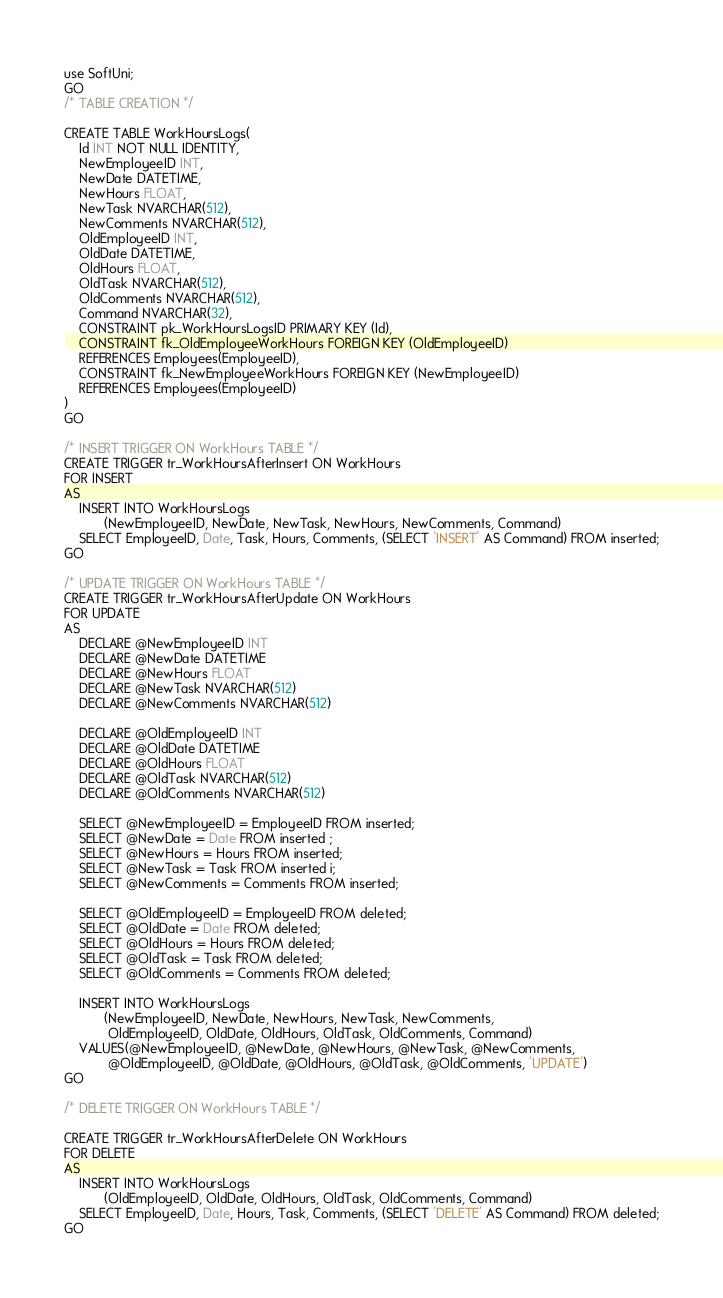Convert code to text. <code><loc_0><loc_0><loc_500><loc_500><_SQL_>use SoftUni;
GO
/* TABLE CREATION */

CREATE TABLE WorkHoursLogs(
	Id INT NOT NULL IDENTITY,
	NewEmployeeID INT,
	NewDate DATETIME,
	NewHours FLOAT,
	NewTask NVARCHAR(512),
	NewComments NVARCHAR(512),
	OldEmployeeID INT,
	OldDate DATETIME,
	OldHours FLOAT,
	OldTask NVARCHAR(512),
	OldComments NVARCHAR(512),
	Command NVARCHAR(32),
	CONSTRAINT pk_WorkHoursLogsID PRIMARY KEY (Id),
	CONSTRAINT fk_OldEmployeeWorkHours FOREIGN KEY (OldEmployeeID)
	REFERENCES Employees(EmployeeID),
	CONSTRAINT fk_NewEmployeeWorkHours FOREIGN KEY (NewEmployeeID)
	REFERENCES Employees(EmployeeID)
)
GO

/* INSERT TRIGGER ON WorkHours TABLE */
CREATE TRIGGER tr_WorkHoursAfterInsert ON WorkHours 
FOR INSERT
AS
	INSERT INTO WorkHoursLogs
           (NewEmployeeID, NewDate, NewTask, NewHours, NewComments, Command) 
	SELECT EmployeeID, Date, Task, Hours, Comments, (SELECT 'INSERT' AS Command) FROM inserted;
GO

/* UPDATE TRIGGER ON WorkHours TABLE */
CREATE TRIGGER tr_WorkHoursAfterUpdate ON WorkHours 
FOR UPDATE
AS
	DECLARE @NewEmployeeID INT
	DECLARE @NewDate DATETIME
	DECLARE @NewHours FLOAT
	DECLARE @NewTask NVARCHAR(512)
	DECLARE @NewComments NVARCHAR(512)

	DECLARE @OldEmployeeID INT
	DECLARE @OldDate DATETIME
	DECLARE @OldHours FLOAT
	DECLARE @OldTask NVARCHAR(512)
	DECLARE @OldComments NVARCHAR(512)

	SELECT @NewEmployeeID = EmployeeID FROM inserted;	
	SELECT @NewDate = Date FROM inserted ;
	SELECT @NewHours = Hours FROM inserted;
	SELECT @NewTask = Task FROM inserted i;
	SELECT @NewComments = Comments FROM inserted;

	SELECT @OldEmployeeID = EmployeeID FROM deleted;	
	SELECT @OldDate = Date FROM deleted;
	SELECT @OldHours = Hours FROM deleted;
	SELECT @OldTask = Task FROM deleted;
	SELECT @OldComments = Comments FROM deleted;

	INSERT INTO WorkHoursLogs
           (NewEmployeeID, NewDate, NewHours, NewTask, NewComments,
		    OldEmployeeID, OldDate, OldHours, OldTask, OldComments, Command) 
	VALUES(@NewEmployeeID, @NewDate, @NewHours, @NewTask, @NewComments,
		    @OldEmployeeID, @OldDate, @OldHours, @OldTask, @OldComments, 'UPDATE')
GO

/* DELETE TRIGGER ON WorkHours TABLE */

CREATE TRIGGER tr_WorkHoursAfterDelete ON WorkHours 
FOR DELETE
AS
	INSERT INTO WorkHoursLogs
           (OldEmployeeID, OldDate, OldHours, OldTask, OldComments, Command) 
	SELECT EmployeeID, Date, Hours, Task, Comments, (SELECT 'DELETE' AS Command) FROM deleted;
GO</code> 